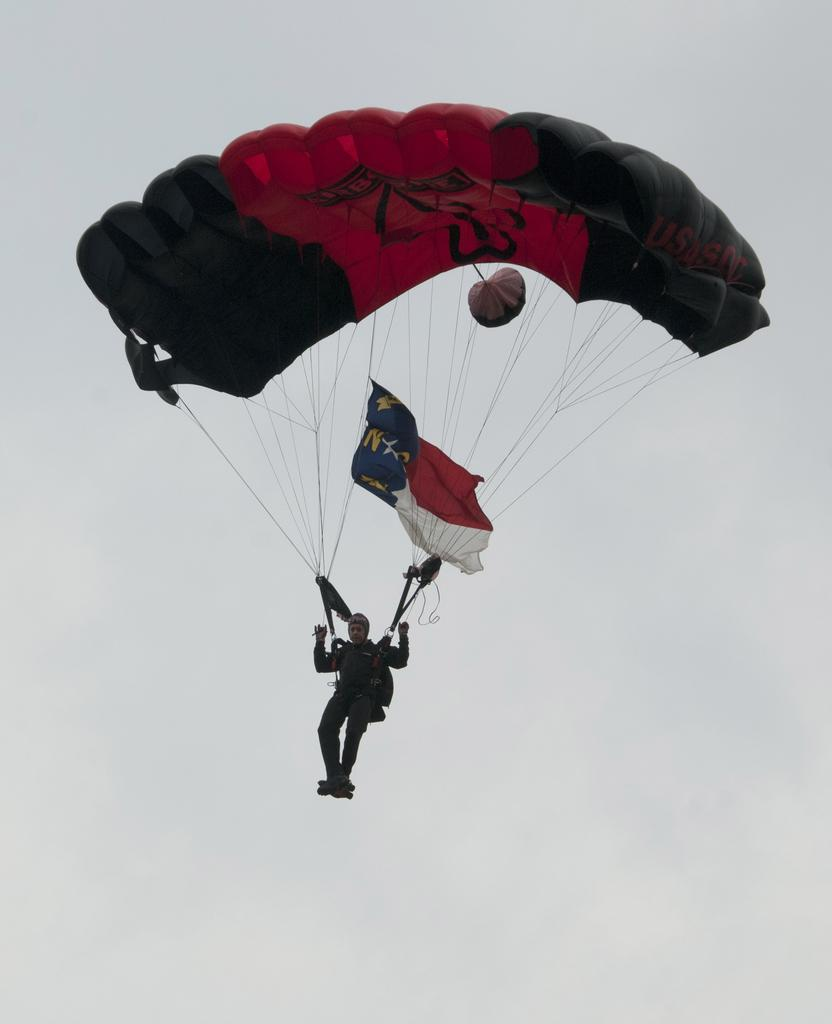What is the main object in the image? There is a parachute in the image. Who is holding the parachute strings? A man is holding the strings of the parachute. Where is the man in the image? The man is in the air. What else is attached to the parachute? There are flags attached to the parachute. What type of car can be seen driving on the base in the image? There is no car or base present in the image; it features a man holding a parachute with flags attached. 